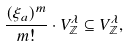Convert formula to latex. <formula><loc_0><loc_0><loc_500><loc_500>\frac { ( \xi _ { a } ) ^ { m } } { m ! } \cdot V _ { \mathbb { Z } } ^ { \lambda } \subseteq V _ { \mathbb { Z } } ^ { \lambda } ,</formula> 